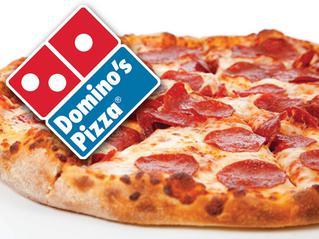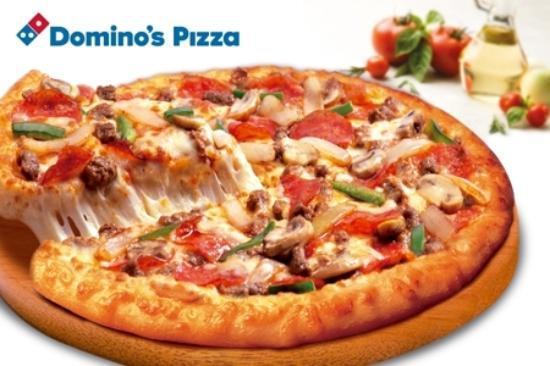The first image is the image on the left, the second image is the image on the right. Considering the images on both sides, is "One slice is being lifted off the pizza." valid? Answer yes or no. Yes. The first image is the image on the left, the second image is the image on the right. Evaluate the accuracy of this statement regarding the images: "The right image shows a slice of pizza lifted upward, with cheese stretching along its side, from a round pie, and the left image includes a whole round pizza.". Is it true? Answer yes or no. Yes. 